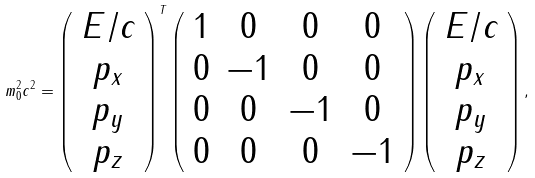<formula> <loc_0><loc_0><loc_500><loc_500>m _ { 0 } ^ { 2 } c ^ { 2 } = \left ( \begin{array} { c } E / c \\ p _ { x } \\ p _ { y } \\ p _ { z } \end{array} \right ) ^ { T } \left ( \begin{array} { c c c c } 1 & 0 & 0 & 0 \\ 0 & - 1 & 0 & 0 \\ 0 & 0 & - 1 & 0 \\ 0 & 0 & 0 & - 1 \end{array} \right ) \left ( \begin{array} { c } E / c \\ p _ { x } \\ p _ { y } \\ p _ { z } \end{array} \right ) ,</formula> 